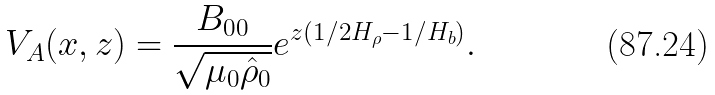Convert formula to latex. <formula><loc_0><loc_0><loc_500><loc_500>V _ { A } ( x , z ) = \frac { B _ { 0 0 } } { \sqrt { \mu _ { 0 } \hat { \rho } _ { 0 } } } e ^ { z \left ( 1 / 2 H _ { \rho } - 1 / H _ { b } \right ) } .</formula> 